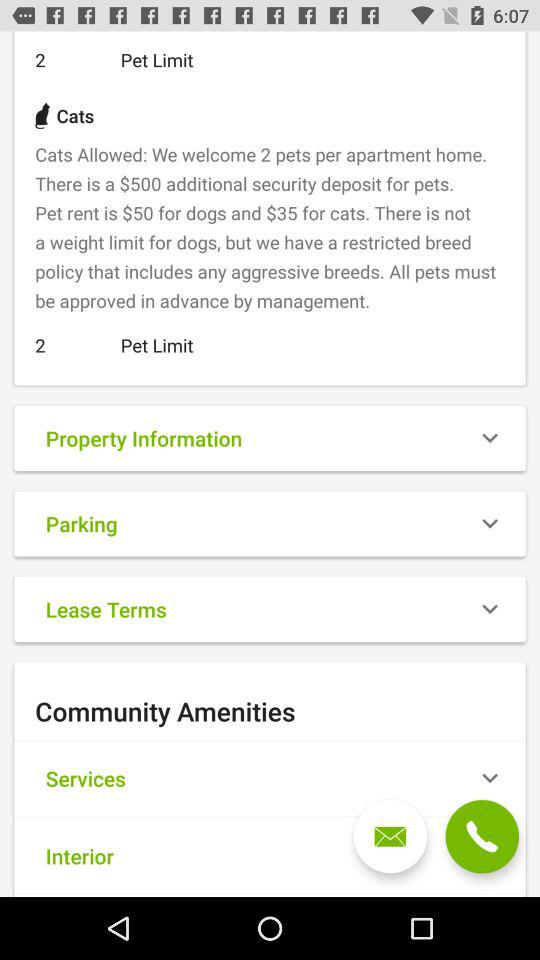How many more dollars is the pet rent for dogs than cats?
Answer the question using a single word or phrase. 15 